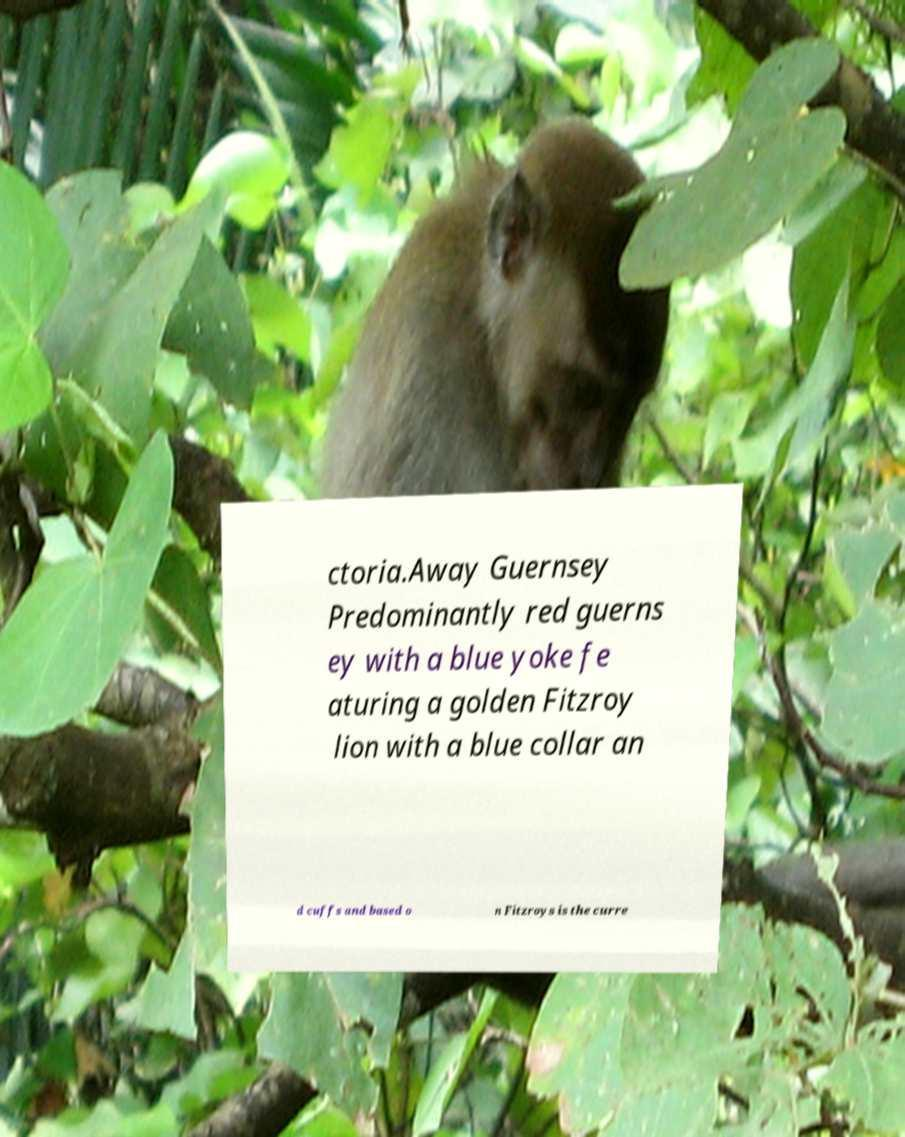Could you assist in decoding the text presented in this image and type it out clearly? ctoria.Away Guernsey Predominantly red guerns ey with a blue yoke fe aturing a golden Fitzroy lion with a blue collar an d cuffs and based o n Fitzroys is the curre 